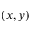<formula> <loc_0><loc_0><loc_500><loc_500>( x , y )</formula> 